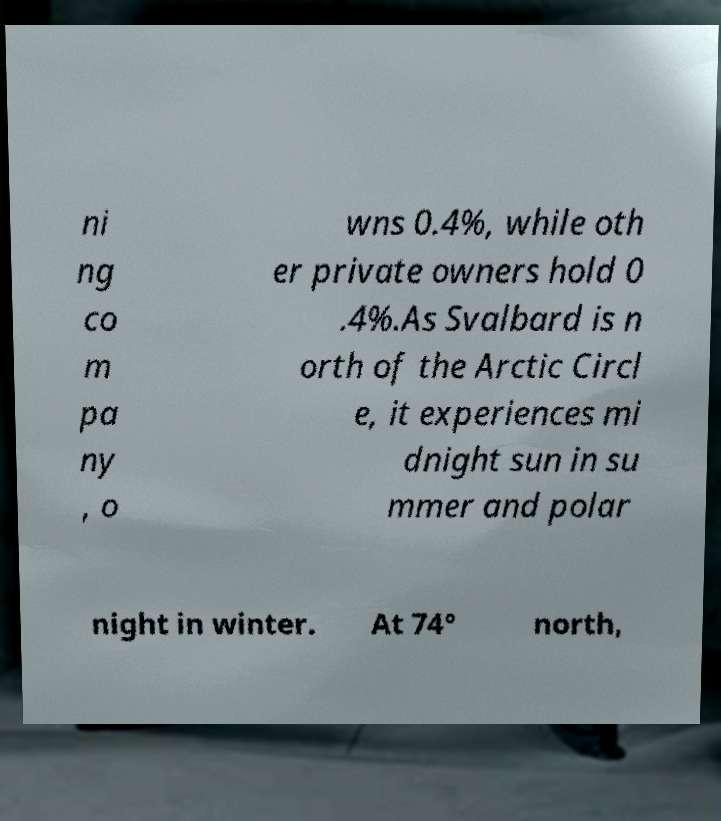Could you assist in decoding the text presented in this image and type it out clearly? ni ng co m pa ny , o wns 0.4%, while oth er private owners hold 0 .4%.As Svalbard is n orth of the Arctic Circl e, it experiences mi dnight sun in su mmer and polar night in winter. At 74° north, 